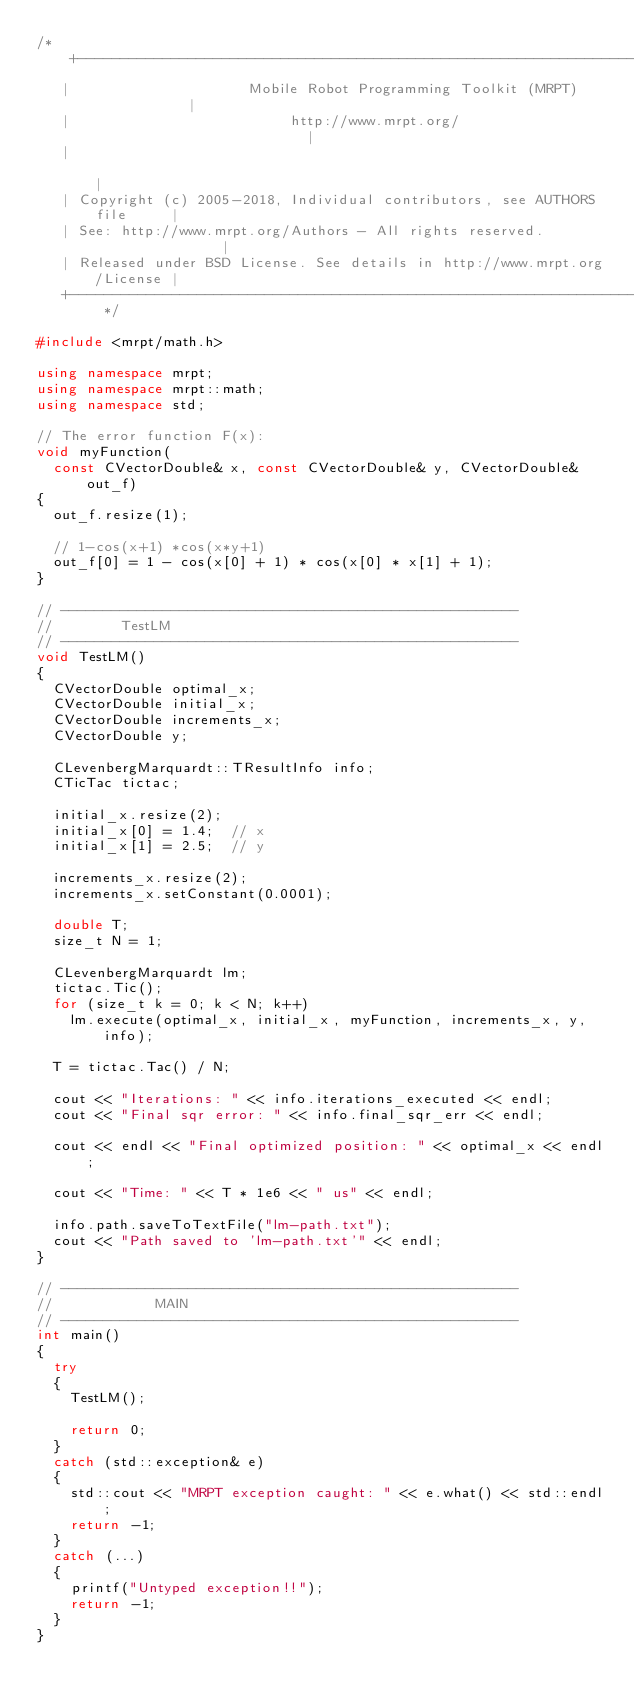Convert code to text. <code><loc_0><loc_0><loc_500><loc_500><_C++_>/* +------------------------------------------------------------------------+
   |                     Mobile Robot Programming Toolkit (MRPT)            |
   |                          http://www.mrpt.org/                          |
   |                                                                        |
   | Copyright (c) 2005-2018, Individual contributors, see AUTHORS file     |
   | See: http://www.mrpt.org/Authors - All rights reserved.                |
   | Released under BSD License. See details in http://www.mrpt.org/License |
   +------------------------------------------------------------------------+ */

#include <mrpt/math.h>

using namespace mrpt;
using namespace mrpt::math;
using namespace std;

// The error function F(x):
void myFunction(
	const CVectorDouble& x, const CVectorDouble& y, CVectorDouble& out_f)
{
	out_f.resize(1);

	// 1-cos(x+1) *cos(x*y+1)
	out_f[0] = 1 - cos(x[0] + 1) * cos(x[0] * x[1] + 1);
}

// ------------------------------------------------------
//				TestLM
// ------------------------------------------------------
void TestLM()
{
	CVectorDouble optimal_x;
	CVectorDouble initial_x;
	CVectorDouble increments_x;
	CVectorDouble y;

	CLevenbergMarquardt::TResultInfo info;
	CTicTac tictac;

	initial_x.resize(2);
	initial_x[0] = 1.4;  // x
	initial_x[1] = 2.5;  // y

	increments_x.resize(2);
	increments_x.setConstant(0.0001);

	double T;
	size_t N = 1;

	CLevenbergMarquardt lm;
	tictac.Tic();
	for (size_t k = 0; k < N; k++)
		lm.execute(optimal_x, initial_x, myFunction, increments_x, y, info);

	T = tictac.Tac() / N;

	cout << "Iterations: " << info.iterations_executed << endl;
	cout << "Final sqr error: " << info.final_sqr_err << endl;

	cout << endl << "Final optimized position: " << optimal_x << endl;

	cout << "Time: " << T * 1e6 << " us" << endl;

	info.path.saveToTextFile("lm-path.txt");
	cout << "Path saved to 'lm-path.txt'" << endl;
}

// ------------------------------------------------------
//						MAIN
// ------------------------------------------------------
int main()
{
	try
	{
		TestLM();

		return 0;
	}
	catch (std::exception& e)
	{
		std::cout << "MRPT exception caught: " << e.what() << std::endl;
		return -1;
	}
	catch (...)
	{
		printf("Untyped exception!!");
		return -1;
	}
}
</code> 